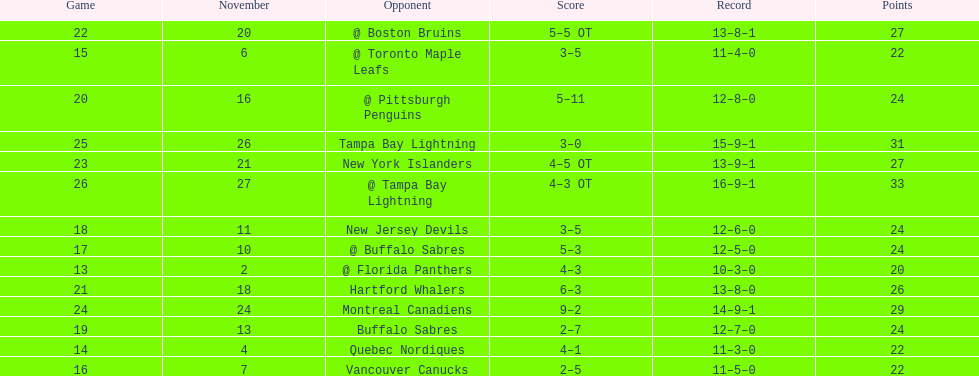Did the tampa bay lightning have the least amount of wins? Yes. 